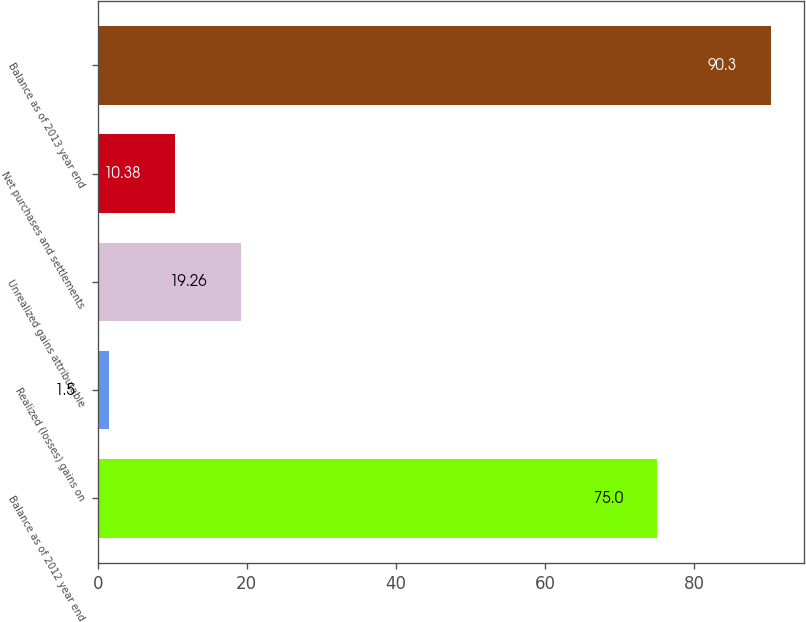Convert chart. <chart><loc_0><loc_0><loc_500><loc_500><bar_chart><fcel>Balance as of 2012 year end<fcel>Realized (losses) gains on<fcel>Unrealized gains attributable<fcel>Net purchases and settlements<fcel>Balance as of 2013 year end<nl><fcel>75<fcel>1.5<fcel>19.26<fcel>10.38<fcel>90.3<nl></chart> 